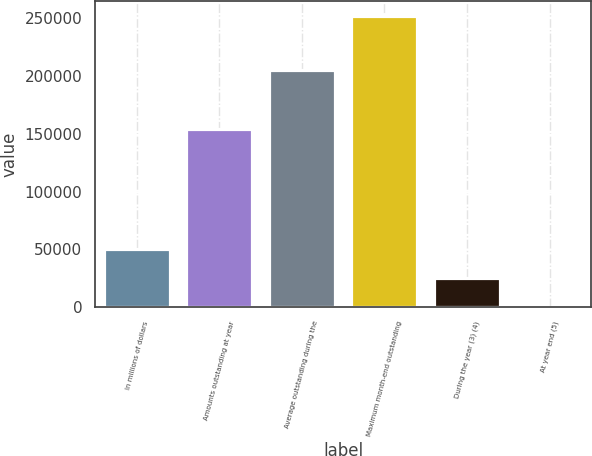<chart> <loc_0><loc_0><loc_500><loc_500><bar_chart><fcel>In millions of dollars<fcel>Amounts outstanding at year<fcel>Average outstanding during the<fcel>Maximum month-end outstanding<fcel>During the year (3) (4)<fcel>At year end (5)<nl><fcel>50431.5<fcel>154281<fcel>205633<fcel>252154<fcel>25216.2<fcel>0.85<nl></chart> 